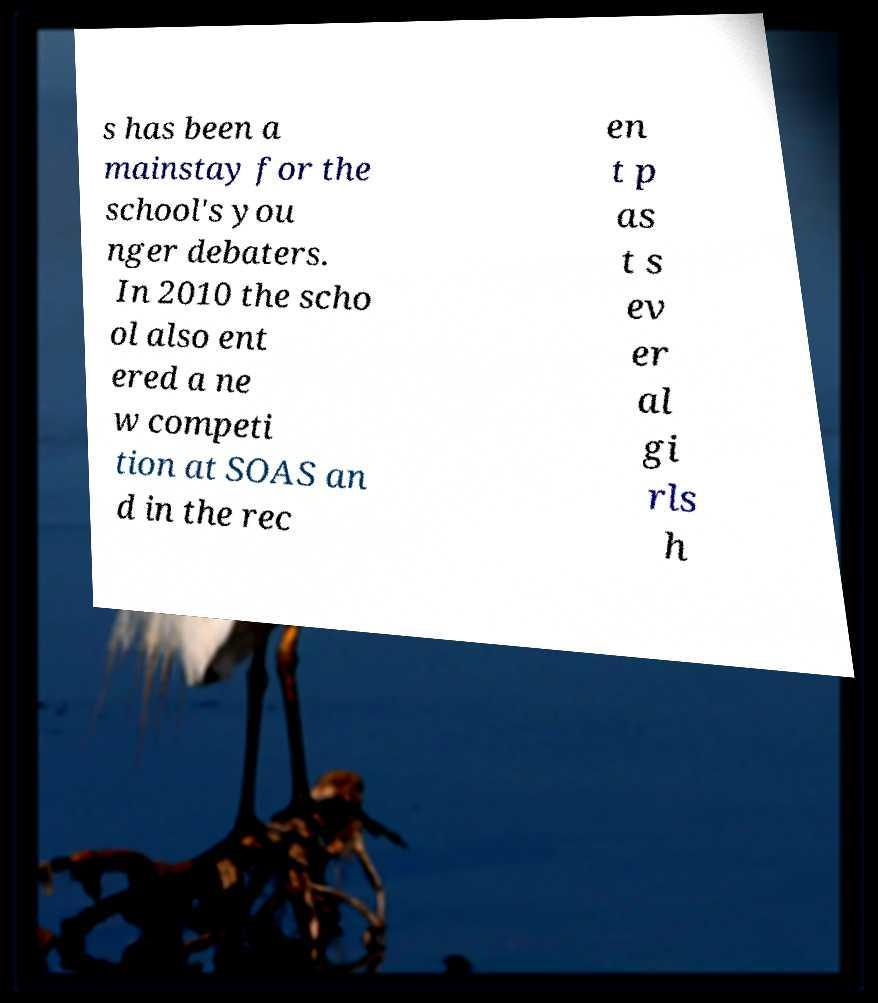Could you assist in decoding the text presented in this image and type it out clearly? s has been a mainstay for the school's you nger debaters. In 2010 the scho ol also ent ered a ne w competi tion at SOAS an d in the rec en t p as t s ev er al gi rls h 